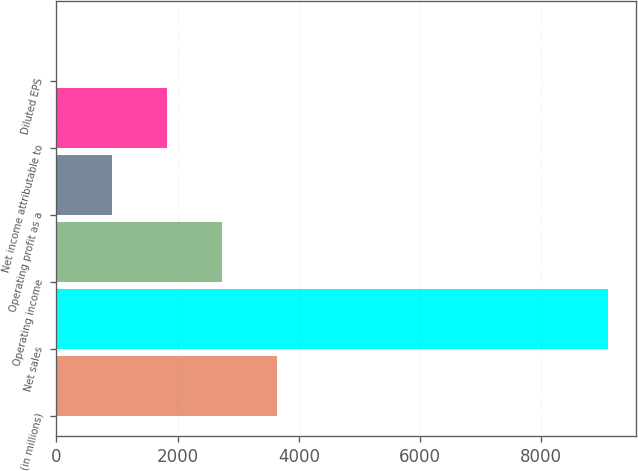Convert chart. <chart><loc_0><loc_0><loc_500><loc_500><bar_chart><fcel>(in millions)<fcel>Net sales<fcel>Operating income<fcel>Operating profit as a<fcel>Net income attributable to<fcel>Diluted EPS<nl><fcel>3640.68<fcel>9101<fcel>2730.63<fcel>910.53<fcel>1820.58<fcel>0.48<nl></chart> 